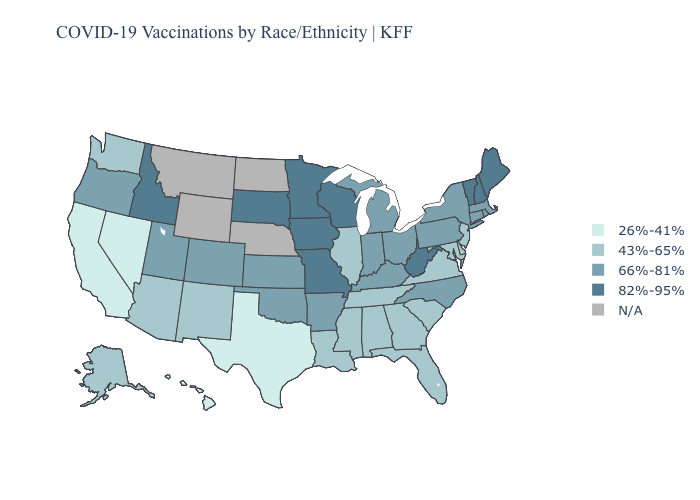Which states have the lowest value in the USA?
Give a very brief answer. California, Hawaii, Nevada, Texas. What is the value of Illinois?
Give a very brief answer. 43%-65%. Name the states that have a value in the range 82%-95%?
Be succinct. Idaho, Iowa, Maine, Minnesota, Missouri, New Hampshire, South Dakota, Vermont, West Virginia, Wisconsin. Does Missouri have the highest value in the MidWest?
Concise answer only. Yes. Does Delaware have the lowest value in the USA?
Short answer required. No. What is the value of Indiana?
Answer briefly. 66%-81%. What is the highest value in states that border Rhode Island?
Short answer required. 66%-81%. Does Utah have the lowest value in the USA?
Concise answer only. No. What is the value of Kentucky?
Give a very brief answer. 66%-81%. Is the legend a continuous bar?
Keep it brief. No. What is the highest value in states that border Ohio?
Give a very brief answer. 82%-95%. Name the states that have a value in the range 66%-81%?
Short answer required. Arkansas, Colorado, Connecticut, Indiana, Kansas, Kentucky, Massachusetts, Michigan, New York, North Carolina, Ohio, Oklahoma, Oregon, Pennsylvania, Rhode Island, Utah. 